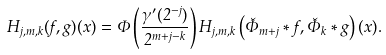<formula> <loc_0><loc_0><loc_500><loc_500>H _ { j , m , k } ( f , g ) ( x ) = \Phi \left ( \frac { \gamma ^ { \prime } ( 2 ^ { - j } ) } { 2 ^ { m + j - k } } \right ) H _ { j , m , k } \left ( \check { \Phi } _ { m + j } \ast f , \check { \Phi } _ { k } \ast g \right ) ( x ) .</formula> 